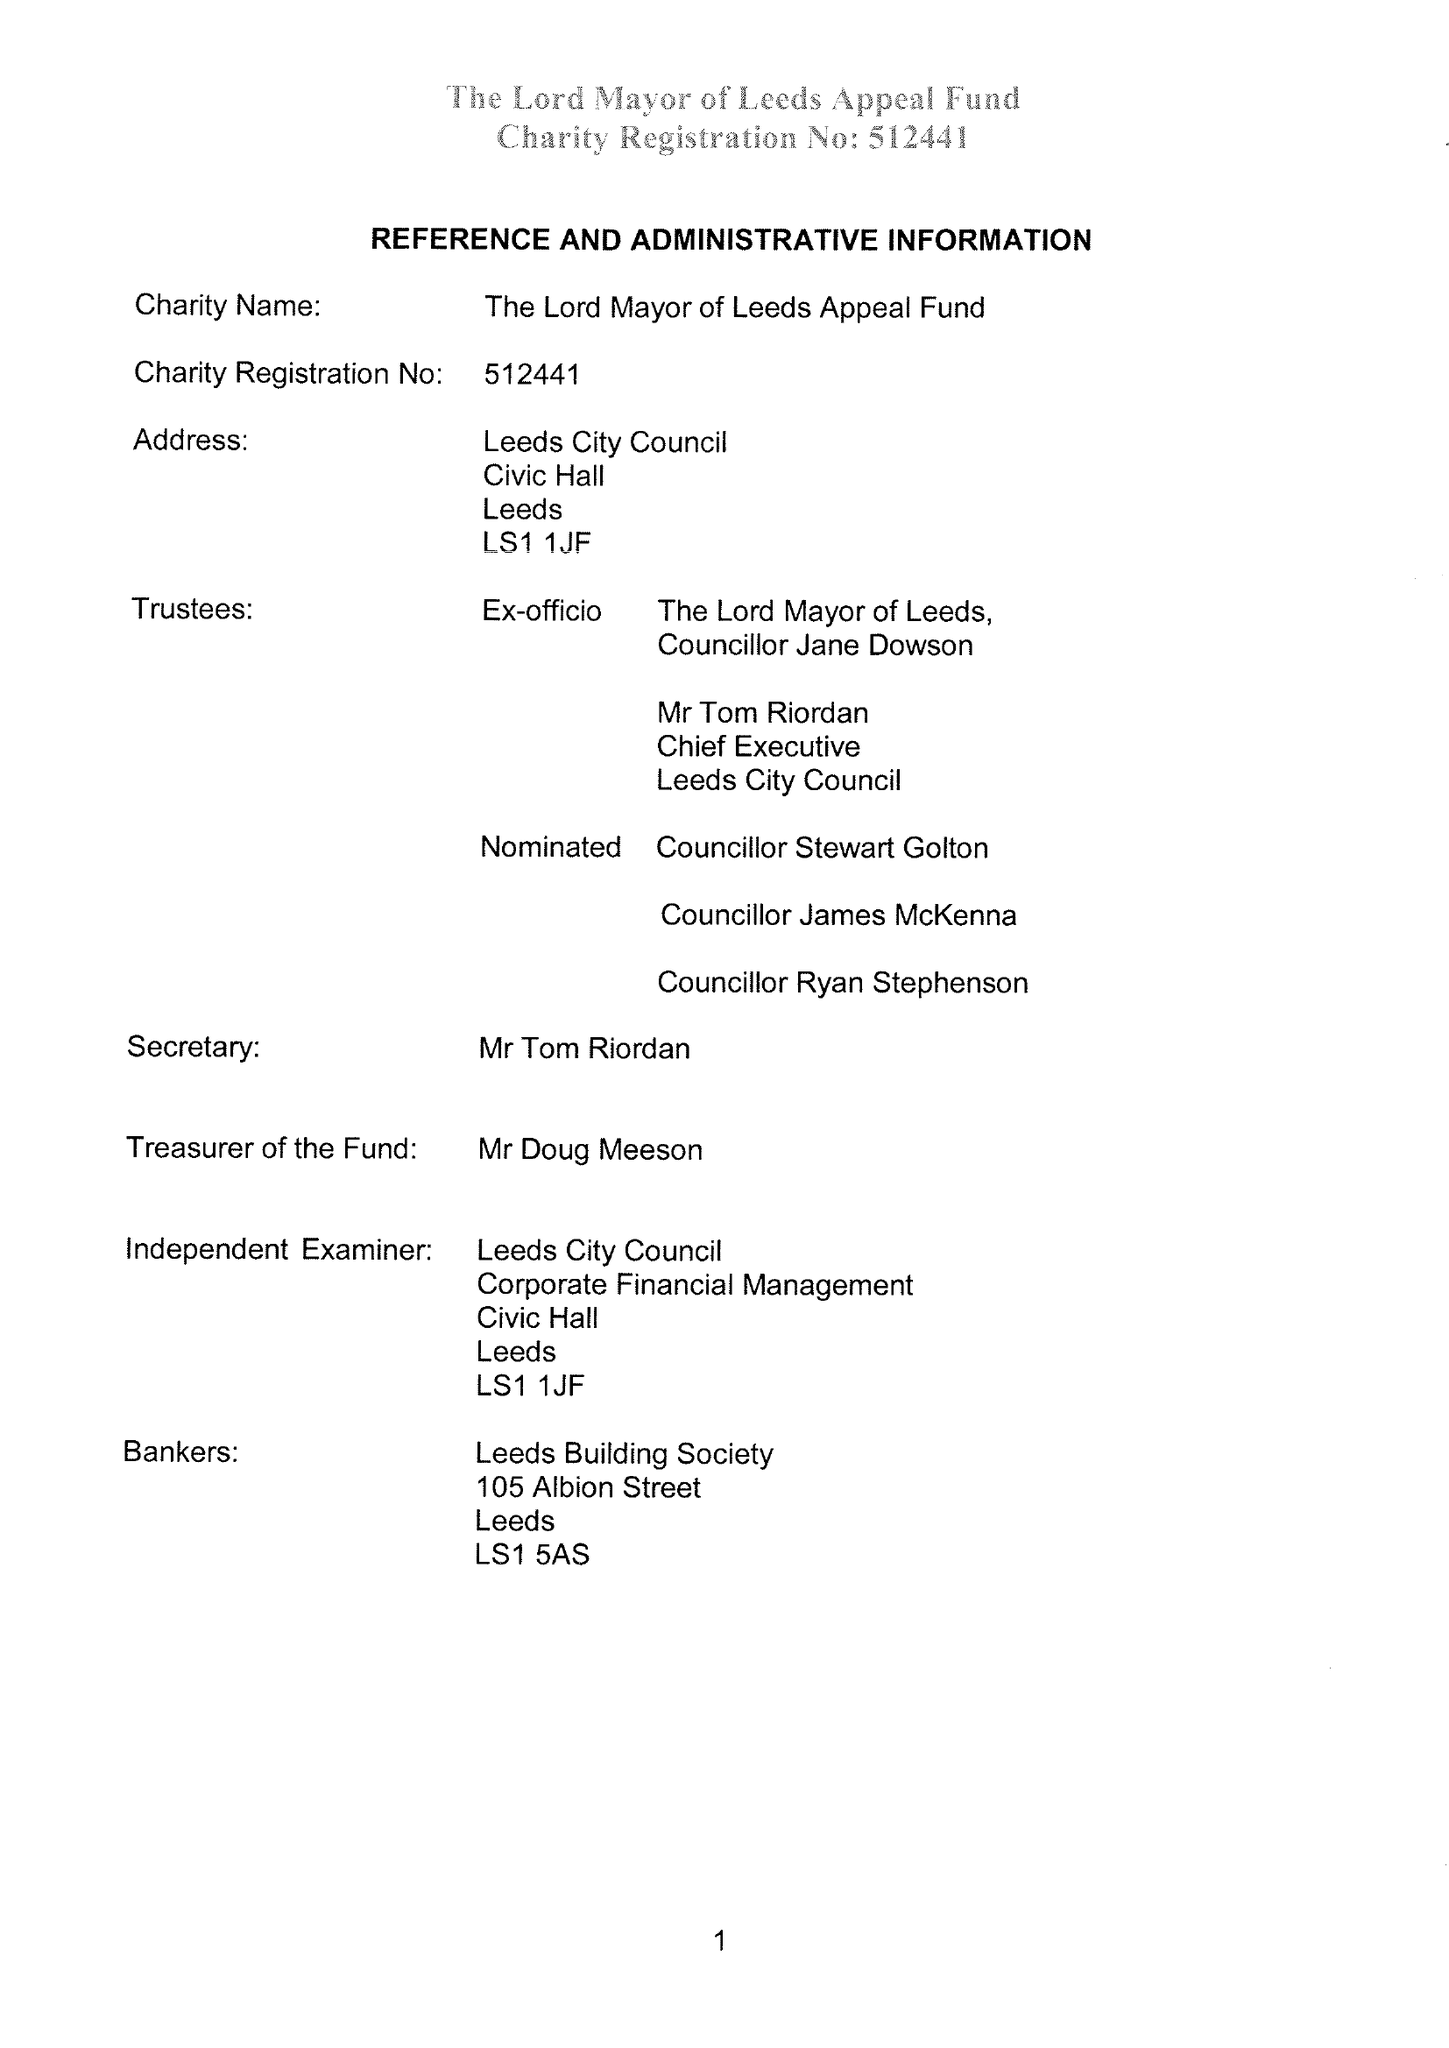What is the value for the address__postcode?
Answer the question using a single word or phrase. LS1 1JF 